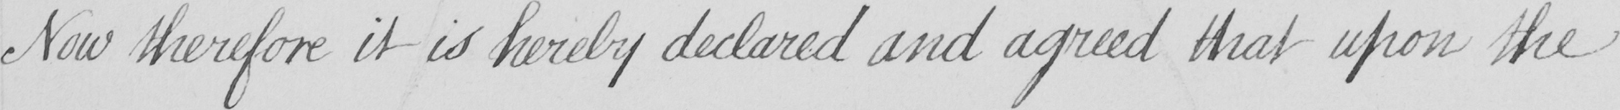What text is written in this handwritten line? Now therefore it is hereby declared and agreed that upon the 